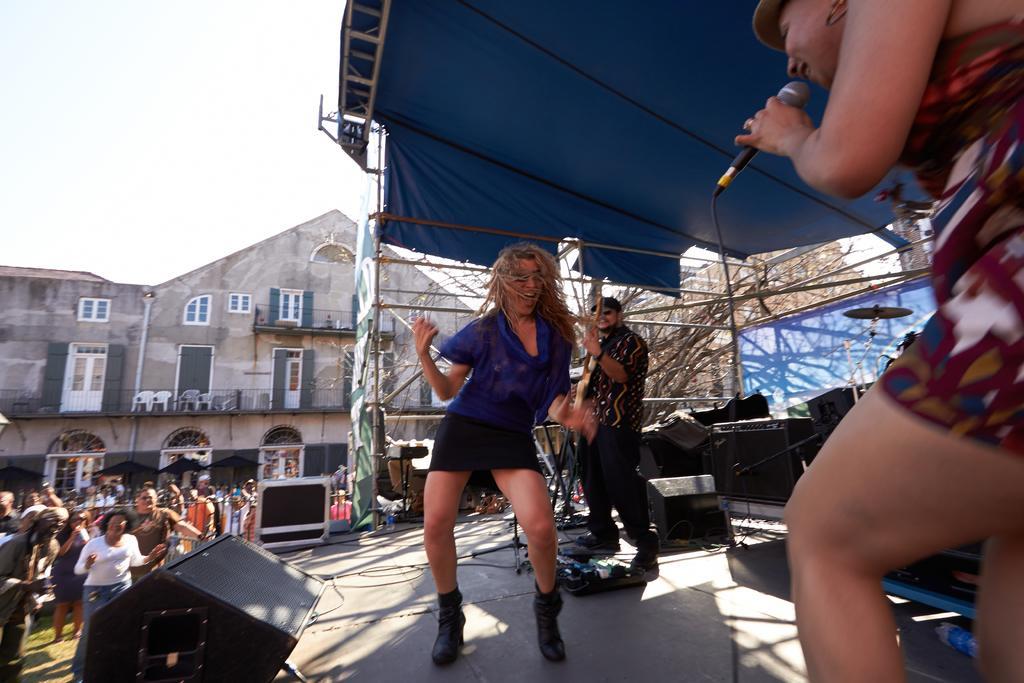How would you summarize this image in a sentence or two? In this image I can see a woman wearing blue dress, black skirt and black shoe and another woman wearing dress and holding a microphone are standing. In the background I can see a person is standing and holding a guitar, the stage, few persons standing on the ground, few speakers, the tent, few buildings, few windows , few trees and the sky. 